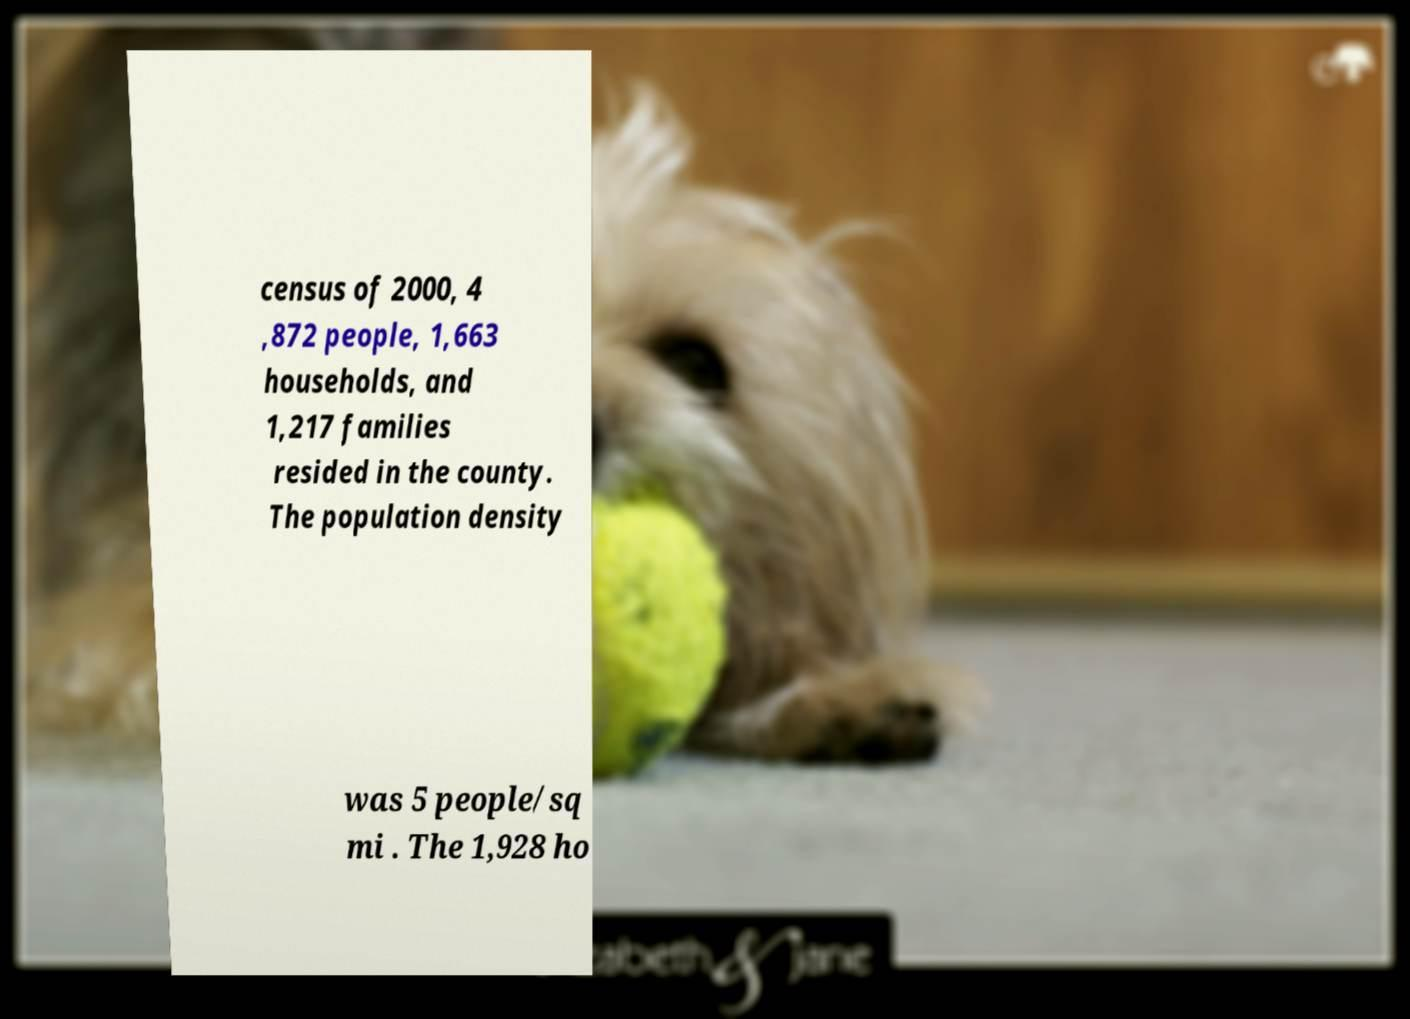Could you assist in decoding the text presented in this image and type it out clearly? census of 2000, 4 ,872 people, 1,663 households, and 1,217 families resided in the county. The population density was 5 people/sq mi . The 1,928 ho 